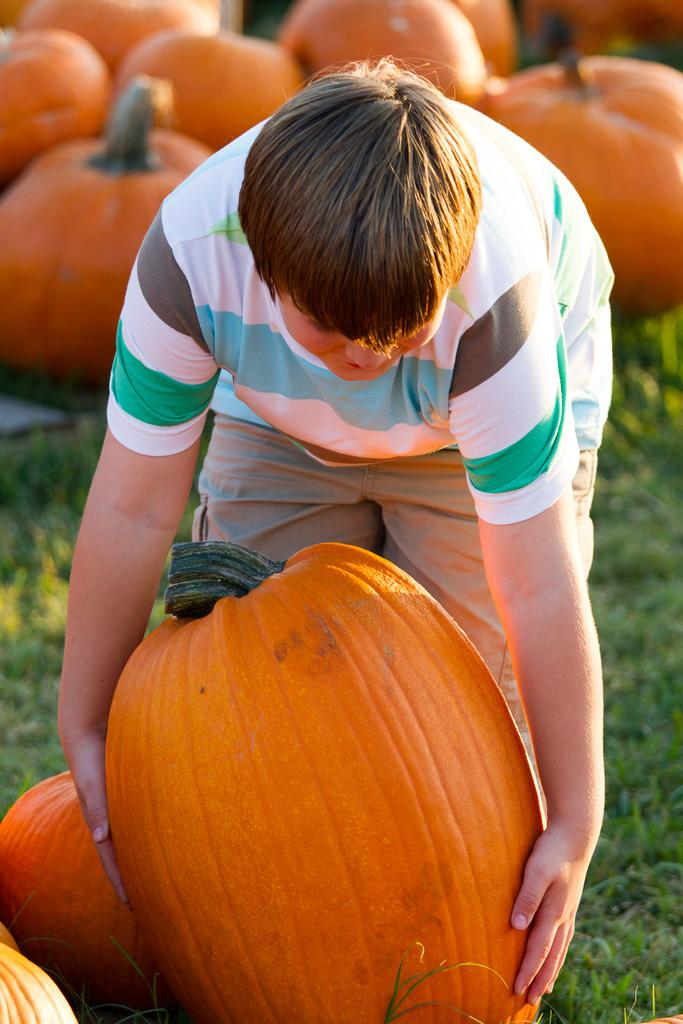Who is the main subject in the image? There is a boy in the image. What is the boy doing in the image? The boy is lifting a pumpkin. What can be seen on the ground in the image? There are many pumpkins on the grass in the image. How many sisters does the boy have in the image? There is no mention of sisters in the image, so we cannot determine the number of sisters the boy has. 